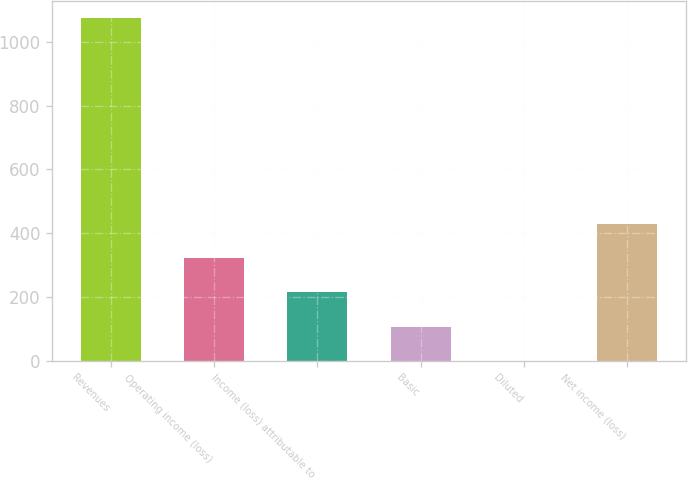Convert chart. <chart><loc_0><loc_0><loc_500><loc_500><bar_chart><fcel>Revenues<fcel>Operating income (loss)<fcel>Income (loss) attributable to<fcel>Basic<fcel>Diluted<fcel>Net income (loss)<nl><fcel>1074<fcel>322.52<fcel>215.17<fcel>107.81<fcel>0.45<fcel>429.88<nl></chart> 